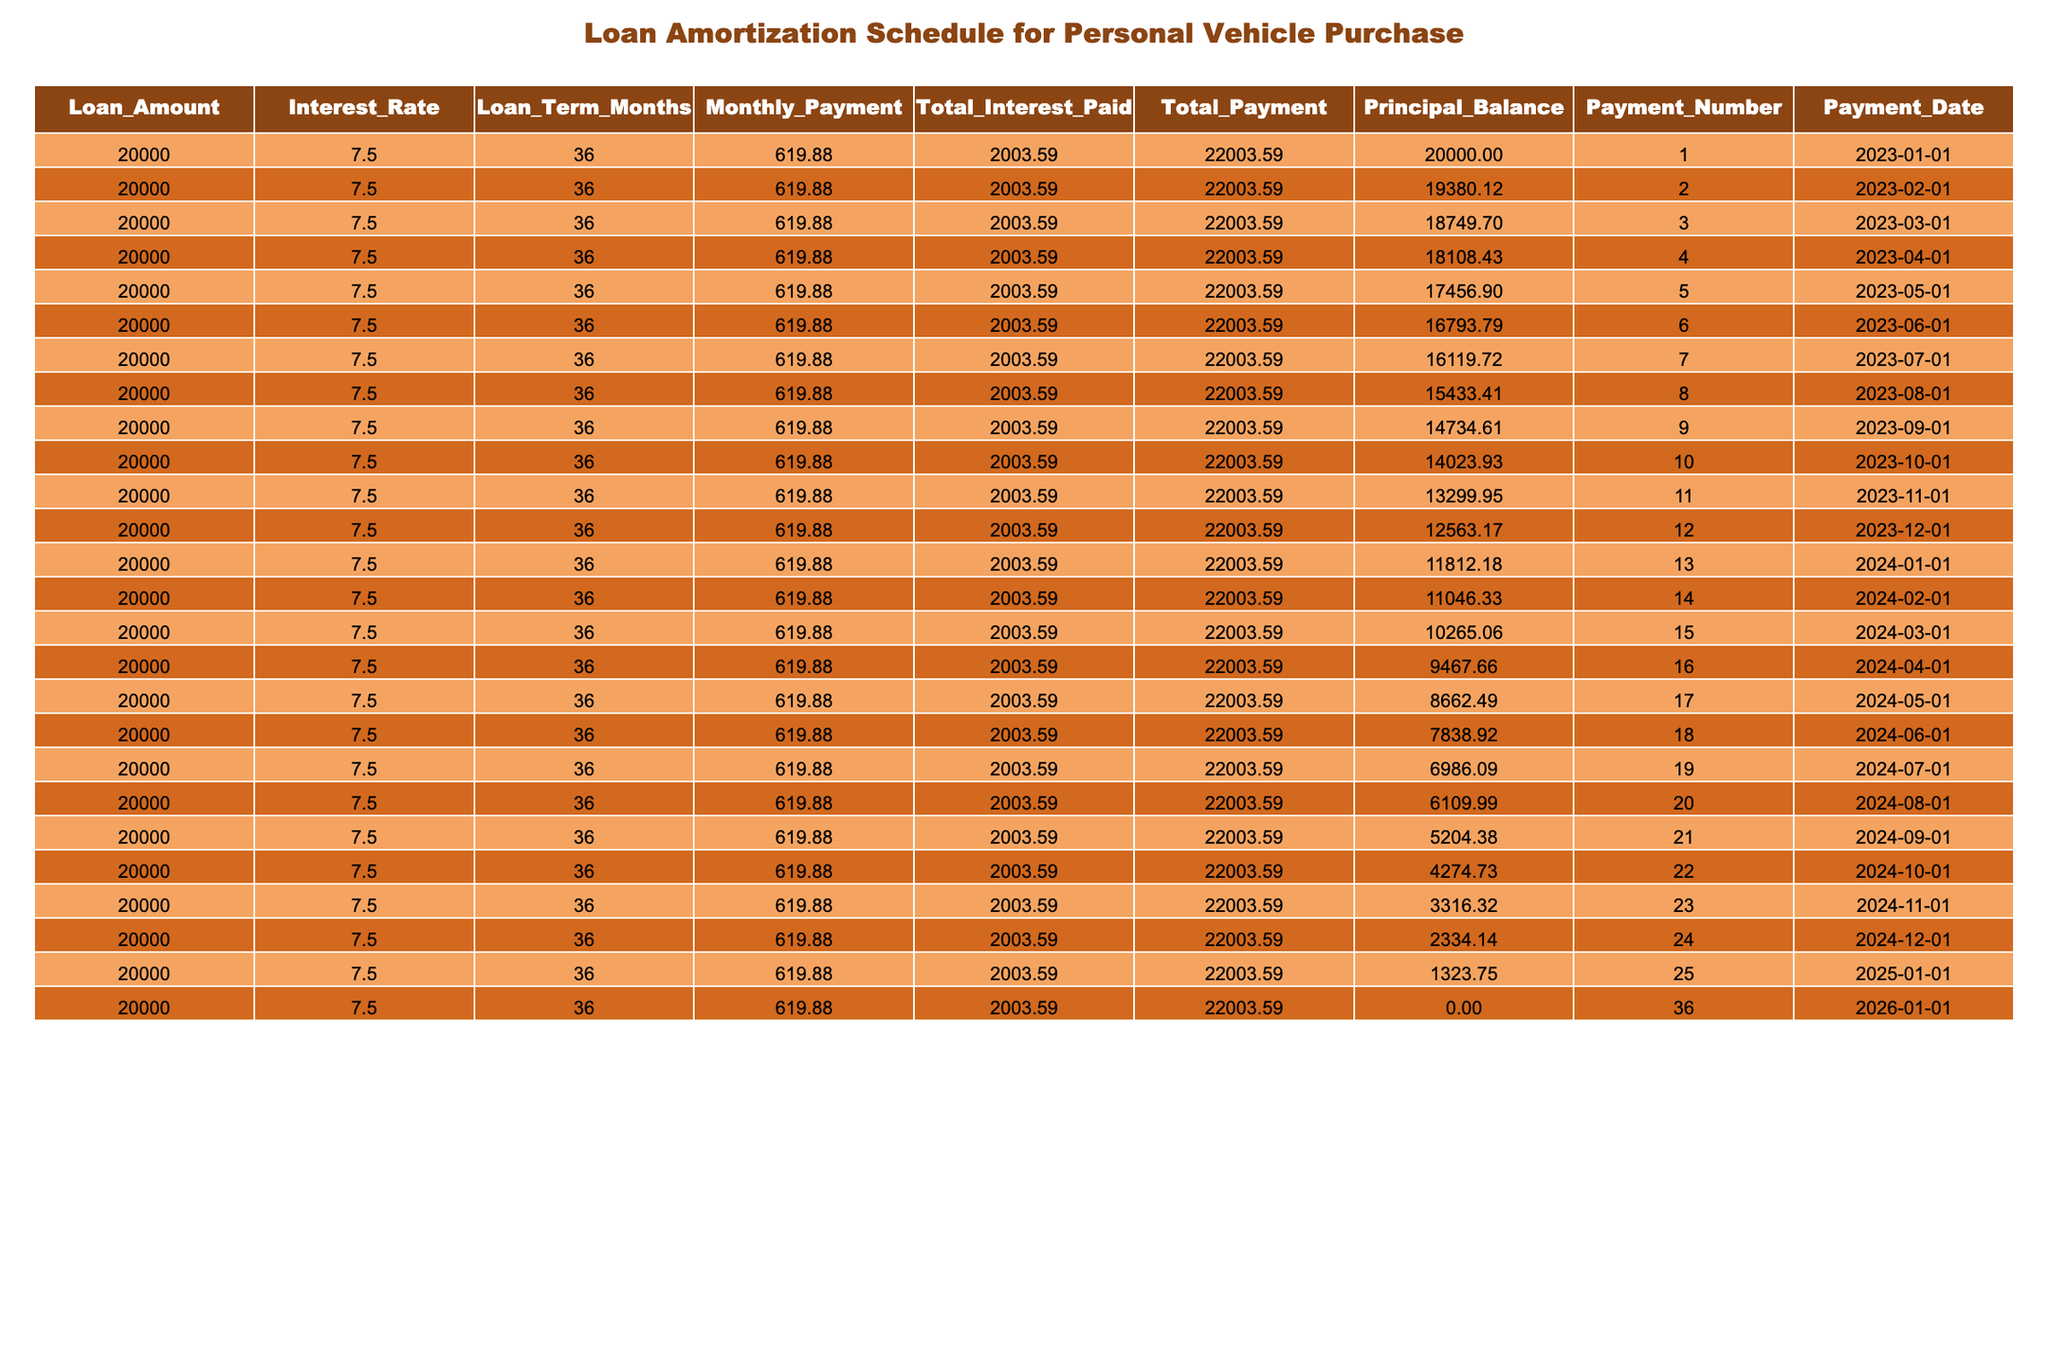What is the total amount paid by the end of the loan term? According to the table, the total payment for the loan is included in the Total_Payment column for the last payment (Payment_Number 36). It shows a value of 22003.59, which indicates the total amount paid over the loan term, including both principal and interest.
Answer: 22003.59 How much interest is paid in total over the life of the loan? The Total_Interest_Paid column shows the total interest amount for the loan, which is noted as 2003.59. This amount is explicitly mentioned in the last row of the table as the total interest incurred throughout the loan.
Answer: 2003.59 What is the principal balance after the first payment? By observing the Principal_Balance column, after the first payment (Payment_Number 1), the balance is 20000 (initial amount) subtracted by the monthly payment amount. Since the remaining balance after the first payment is listed as 19380.12, this indicates the remaining principal.
Answer: 19380.12 Is the monthly payment consistent throughout the loan term? Yes, the Monthly_Payment is fixed at 619.88 for all payments listed in the table. This means the borrower makes the same monthly payment every month throughout the loan term.
Answer: Yes What is the average principal balance by the end of the first half of the loan term? To find the average principal balance for the first half (Payment_Numbers 1-18), we add the principal balances for these payments and then divide by 18 (the number of payments in the first half). The balances from Payment 1 to Payment 18 total (20000 + 19380.12 + ... + 6986.09). Calculating this gives a total of 108595.06, and dividing by 18 results in an average of approximately 6033.06.
Answer: 6033.06 What is the highest principal balance recorded during the loan payments? The highest amount in the Principal_Balance column is noted in the first row, which shows 20000 as this is the starting balance before any payments have been applied.
Answer: 20000 How much has the principal balance decreased after three payments? The principal balance after the third payment (Payment_Number 3) is 18749.70. The decrease from the original amount of 20000 is calculated by subtracting 18749.70 from 20000, resulting in a difference of 1240.30.
Answer: 1240.30 What is the interest amount paid in the fifth month? The interest amount paid can be deduced from the difference in the Principal_Balance across the months. The balance decreased from 17456.90 (the end of the fifth month) to 16793.79 (the end of the sixth month). The payment for that month is 619.88 minus the principal reduction resulting in an interest of 5.89 for that month based on the rate and payment details. Yet this number can be verified across the payments for accuracy too.
Answer: 5.89 What remains as principal after last payment? The Principal_Balance at the end of the loan term (Payment_Number 36) is indicated as 0.00, which means the total loan is completely paid off after the final payment.
Answer: 0.00 